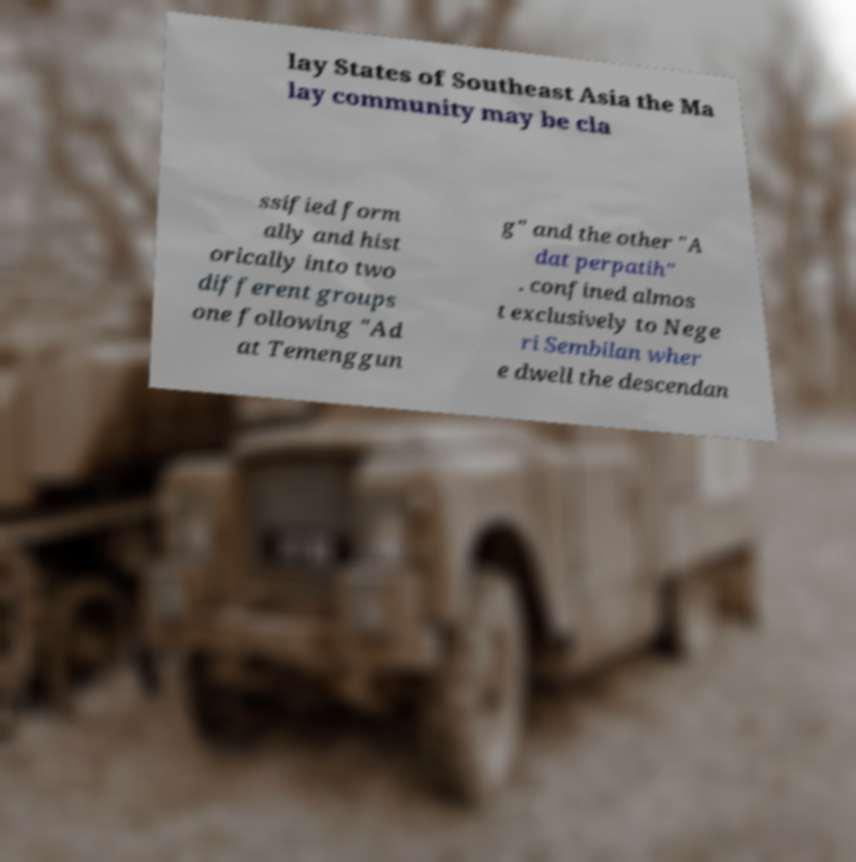Could you assist in decoding the text presented in this image and type it out clearly? lay States of Southeast Asia the Ma lay community may be cla ssified form ally and hist orically into two different groups one following "Ad at Temenggun g" and the other "A dat perpatih" . confined almos t exclusively to Nege ri Sembilan wher e dwell the descendan 